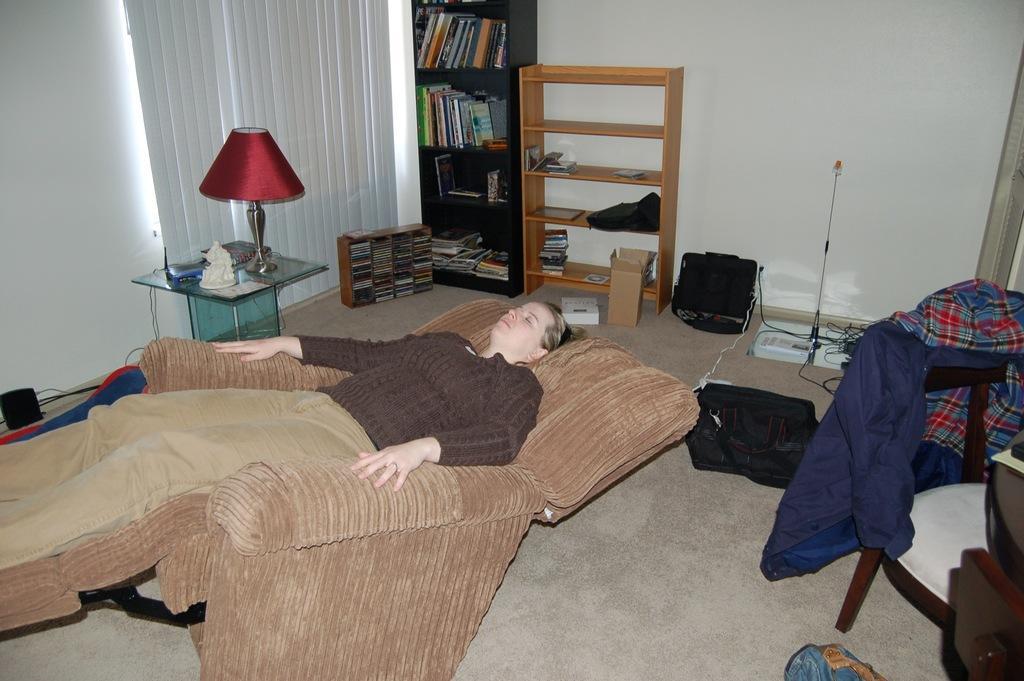How would you summarize this image in a sentence or two? This image is clicked inside a room. There is a man lying on a recliner couch. Beside him there is a table. On the table there are sculptures, a table lamp and a telephone. Behind the table there are window blinds to the wall. To the right there is a chair. There is a jacket spread on the chair. In the background there is a wall. There are racks near the wall. There are books in the racks. There are bags, cable wires and boxes on the floor. There is carpet on the floor. 